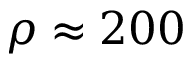Convert formula to latex. <formula><loc_0><loc_0><loc_500><loc_500>\rho \approx 2 0 0</formula> 